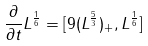<formula> <loc_0><loc_0><loc_500><loc_500>\frac { \partial } { \partial t } L ^ { \frac { 1 } { 6 } } = [ 9 ( L ^ { \frac { 5 } { 3 } } ) _ { + } , L ^ { \frac { 1 } { 6 } } ]</formula> 